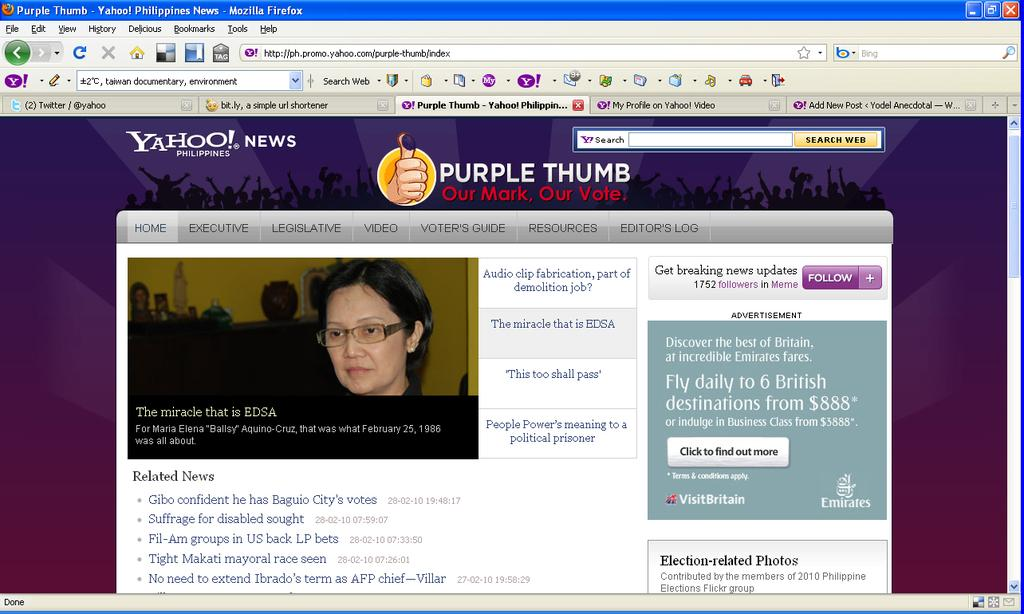What is the main subject of the image? The main subject of the image is a screen of a website. What type of polish is being applied to the teeth in the image? There is no image of teeth or polish being applied in the image; it contains a screen of a website. 